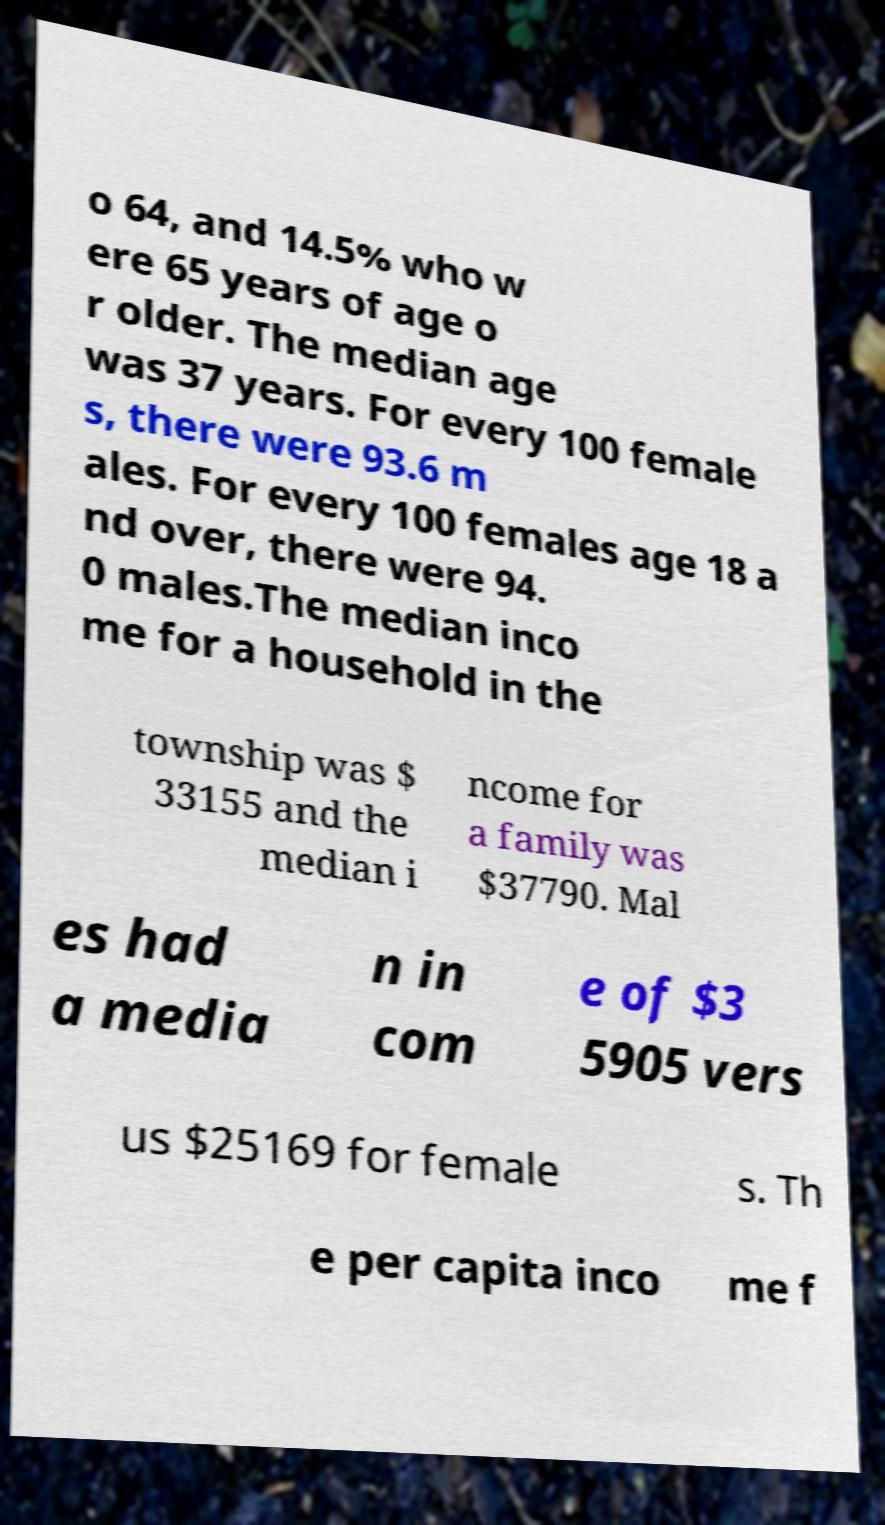For documentation purposes, I need the text within this image transcribed. Could you provide that? o 64, and 14.5% who w ere 65 years of age o r older. The median age was 37 years. For every 100 female s, there were 93.6 m ales. For every 100 females age 18 a nd over, there were 94. 0 males.The median inco me for a household in the township was $ 33155 and the median i ncome for a family was $37790. Mal es had a media n in com e of $3 5905 vers us $25169 for female s. Th e per capita inco me f 